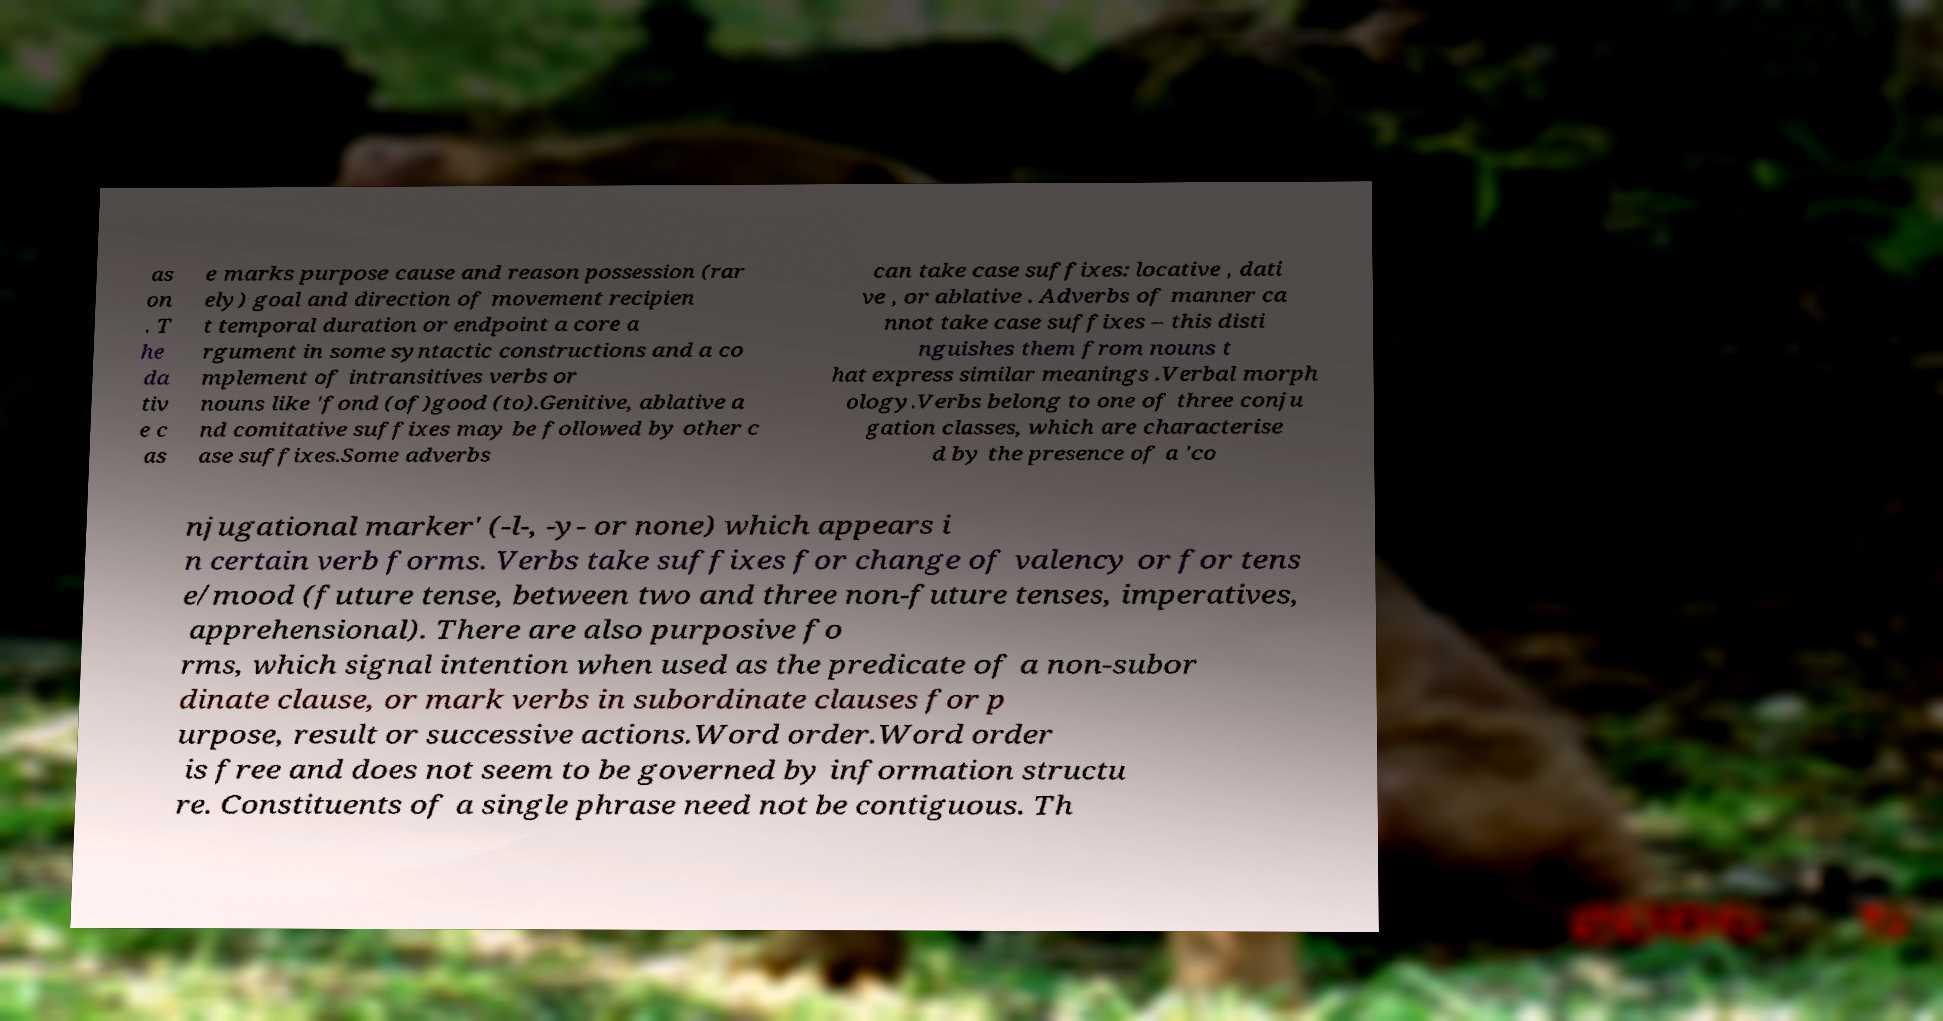For documentation purposes, I need the text within this image transcribed. Could you provide that? as on . T he da tiv e c as e marks purpose cause and reason possession (rar ely) goal and direction of movement recipien t temporal duration or endpoint a core a rgument in some syntactic constructions and a co mplement of intransitives verbs or nouns like 'fond (of)good (to).Genitive, ablative a nd comitative suffixes may be followed by other c ase suffixes.Some adverbs can take case suffixes: locative , dati ve , or ablative . Adverbs of manner ca nnot take case suffixes – this disti nguishes them from nouns t hat express similar meanings .Verbal morph ology.Verbs belong to one of three conju gation classes, which are characterise d by the presence of a 'co njugational marker' (-l-, -y- or none) which appears i n certain verb forms. Verbs take suffixes for change of valency or for tens e/mood (future tense, between two and three non-future tenses, imperatives, apprehensional). There are also purposive fo rms, which signal intention when used as the predicate of a non-subor dinate clause, or mark verbs in subordinate clauses for p urpose, result or successive actions.Word order.Word order is free and does not seem to be governed by information structu re. Constituents of a single phrase need not be contiguous. Th 